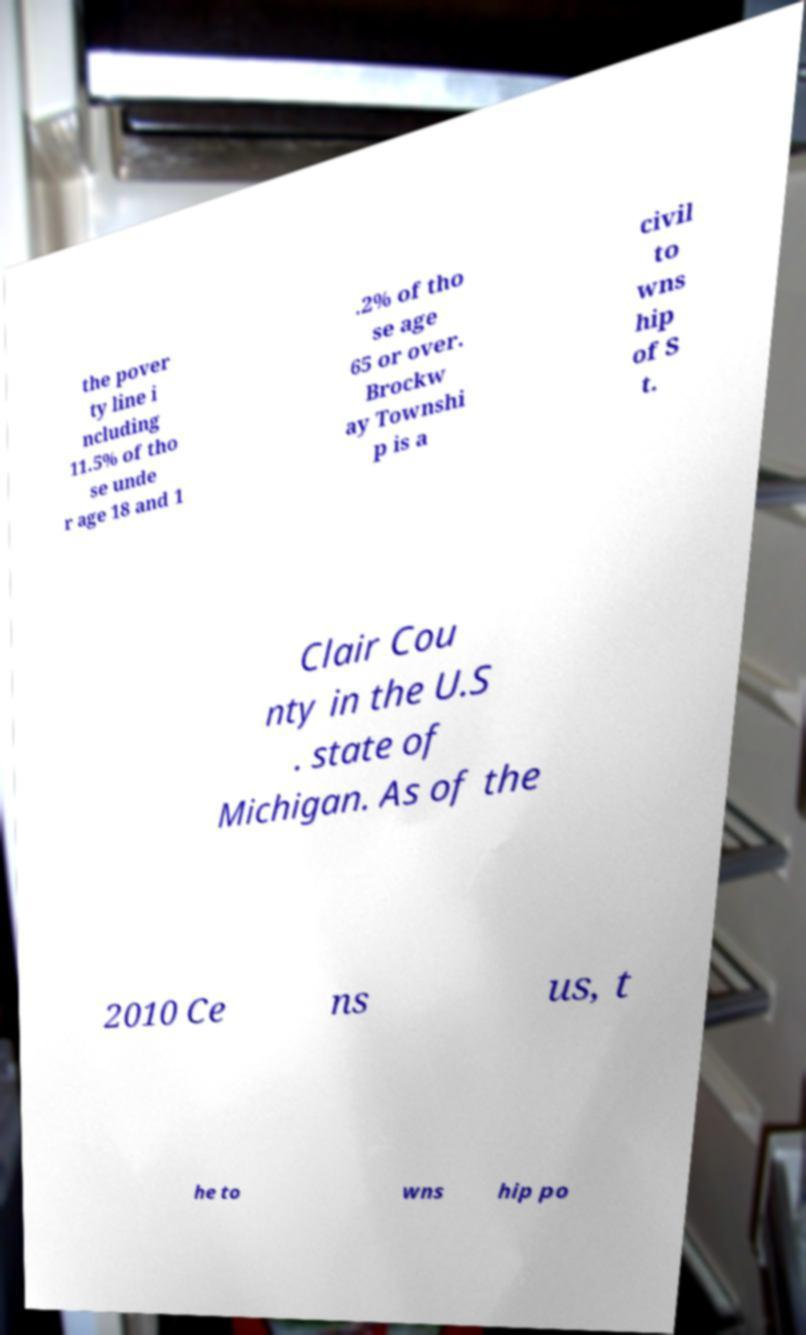Could you assist in decoding the text presented in this image and type it out clearly? the pover ty line i ncluding 11.5% of tho se unde r age 18 and 1 .2% of tho se age 65 or over. Brockw ay Townshi p is a civil to wns hip of S t. Clair Cou nty in the U.S . state of Michigan. As of the 2010 Ce ns us, t he to wns hip po 